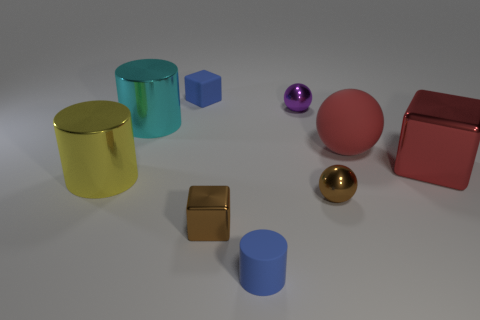Which objects seem to have a smooth surface? The cyan cylinder, the golden sphere, the purple sphere, and the red cube all appear to have smooth surfaces. Are any two objects of the same color and if so, which ones? No, each object in the image has a distinct color; there are no two objects sharing the exact same color. 